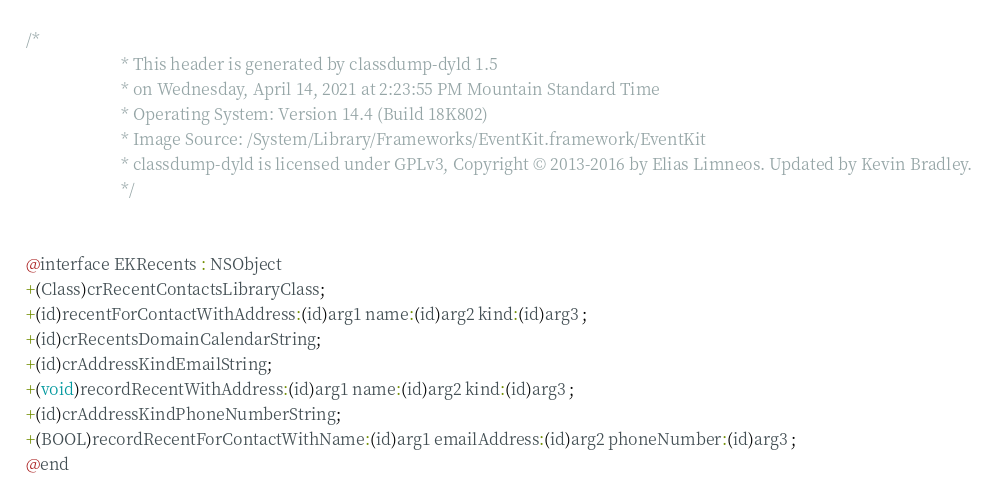<code> <loc_0><loc_0><loc_500><loc_500><_C_>/*
                       * This header is generated by classdump-dyld 1.5
                       * on Wednesday, April 14, 2021 at 2:23:55 PM Mountain Standard Time
                       * Operating System: Version 14.4 (Build 18K802)
                       * Image Source: /System/Library/Frameworks/EventKit.framework/EventKit
                       * classdump-dyld is licensed under GPLv3, Copyright © 2013-2016 by Elias Limneos. Updated by Kevin Bradley.
                       */


@interface EKRecents : NSObject
+(Class)crRecentContactsLibraryClass;
+(id)recentForContactWithAddress:(id)arg1 name:(id)arg2 kind:(id)arg3 ;
+(id)crRecentsDomainCalendarString;
+(id)crAddressKindEmailString;
+(void)recordRecentWithAddress:(id)arg1 name:(id)arg2 kind:(id)arg3 ;
+(id)crAddressKindPhoneNumberString;
+(BOOL)recordRecentForContactWithName:(id)arg1 emailAddress:(id)arg2 phoneNumber:(id)arg3 ;
@end

</code> 